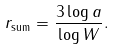<formula> <loc_0><loc_0><loc_500><loc_500>r _ { \text {sum} } = \frac { 3 \log a } { \log W } .</formula> 